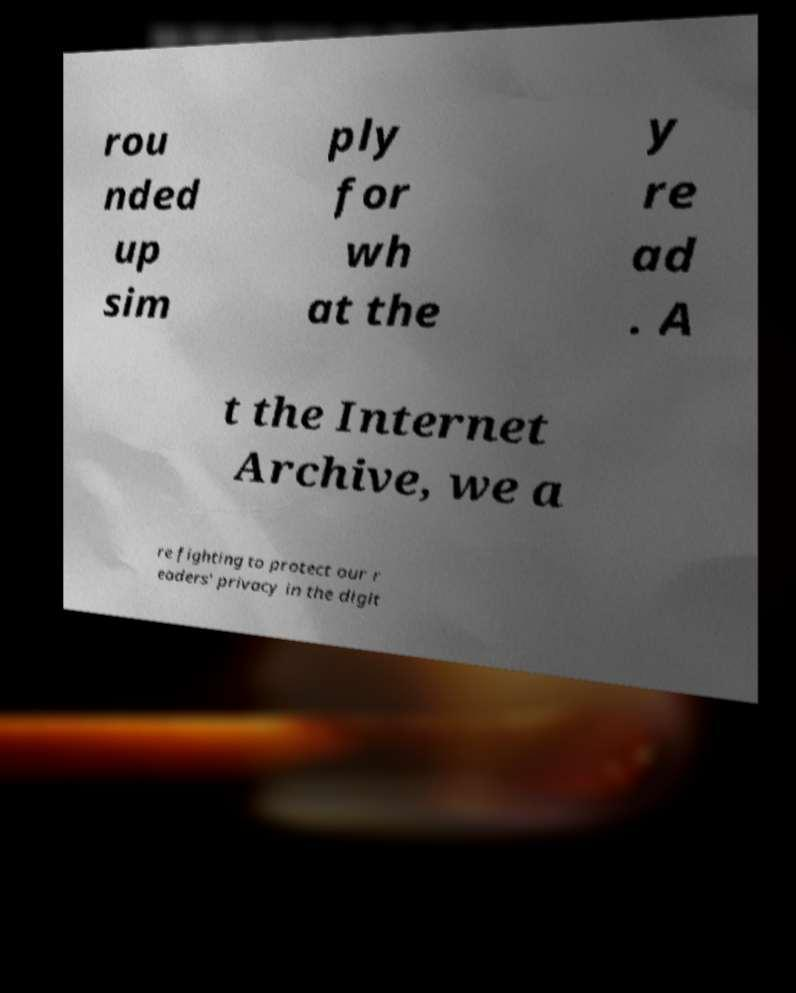Can you accurately transcribe the text from the provided image for me? rou nded up sim ply for wh at the y re ad . A t the Internet Archive, we a re fighting to protect our r eaders' privacy in the digit 